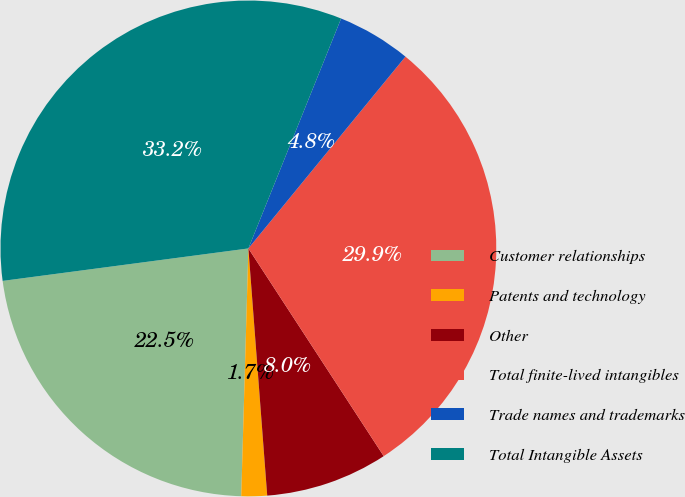<chart> <loc_0><loc_0><loc_500><loc_500><pie_chart><fcel>Customer relationships<fcel>Patents and technology<fcel>Other<fcel>Total finite-lived intangibles<fcel>Trade names and trademarks<fcel>Total Intangible Assets<nl><fcel>22.45%<fcel>1.67%<fcel>7.98%<fcel>29.89%<fcel>4.82%<fcel>33.19%<nl></chart> 